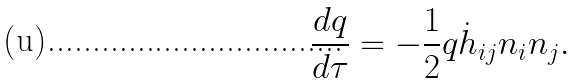Convert formula to latex. <formula><loc_0><loc_0><loc_500><loc_500>\frac { d q } { d \tau } = - \frac { 1 } { 2 } q \dot { h } _ { i j } n _ { i } n _ { j } .</formula> 